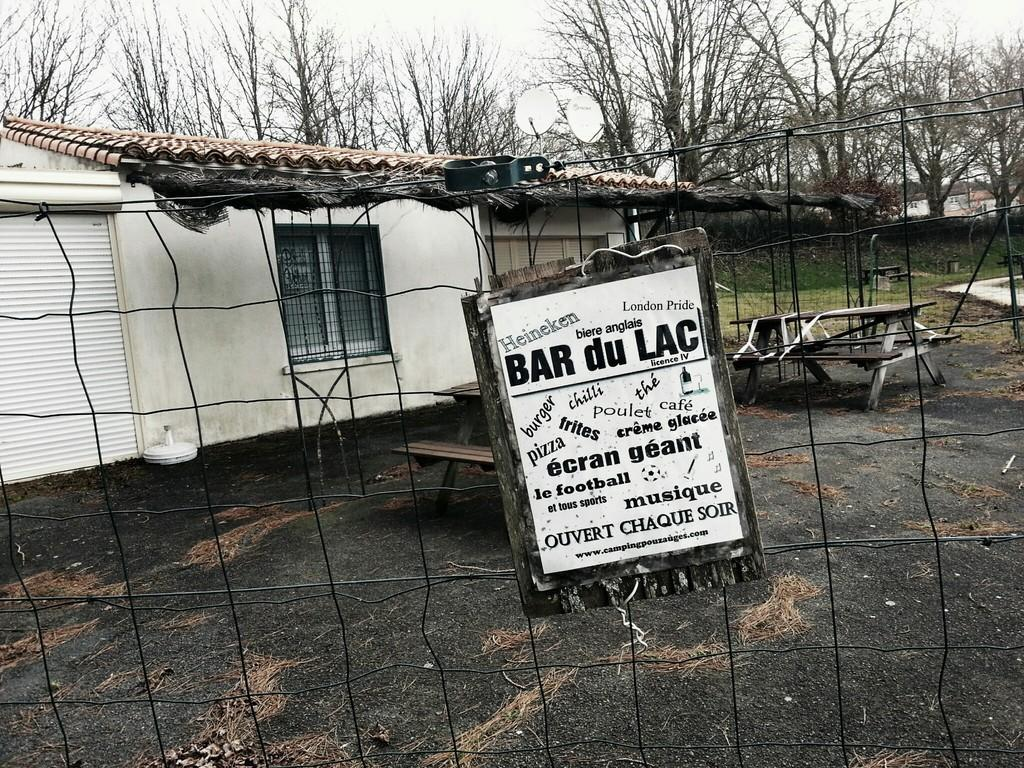<image>
Summarize the visual content of the image. A fence in front of a house that has a sign on it with the word bar. 